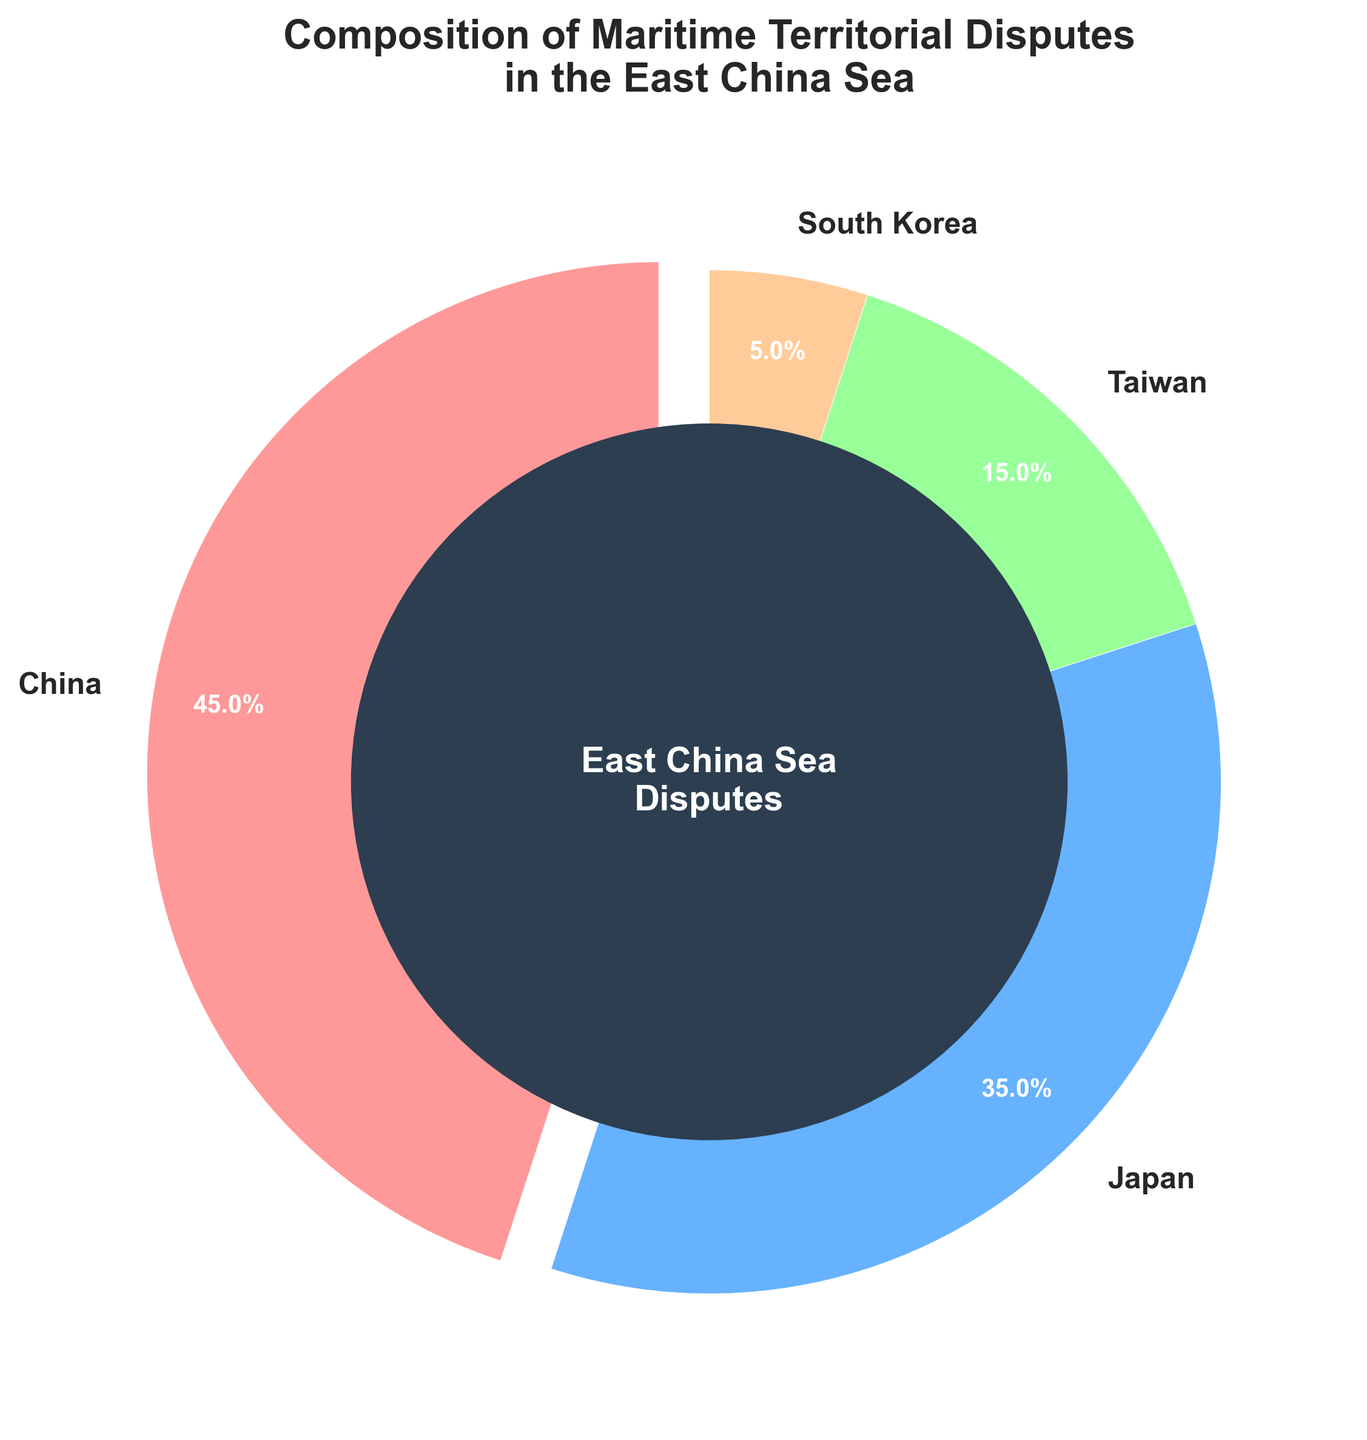What percentage of the disputed area is claimed by Japan and Taiwan together? Japan claims 35% and Taiwan claims 15%. Summing these gives 35% + 15% = 50%.
Answer: 50% Which country claims the smallest percentage of the disputed area? By observing the pie chart, South Korea has the smallest wedge with 5% of the disputed area.
Answer: South Korea How much more disputed area does China claim compared to South Korea? China claims 45% and South Korea claims 5%. The difference is 45% - 5% = 40%.
Answer: 40% Which country claims the largest percentage of the disputed area? By observing the pie chart, China has the largest wedge with 45% of the disputed area.
Answer: China What is the visual color representation of the disputed area claimed by Taiwan? The pie chart shows Taiwan's wedge colored in green.
Answer: Green How does the percentage of the disputed area claimed by Japan compare to that claimed by South Korea? Japan claims 35% and South Korea claims 5%. Japan claims 35% - 5% = 30% more.
Answer: 30% more Describe the visual location of the largest segment in the pie chart. The largest segment is located starting from the 90-degree mark in the clockwise direction and is labeled "China."
Answer: China What is the combined percentage of the disputed area claimed by China and South Korea? China claims 45% and South Korea claims 5%. Summing these gives 45% + 5% = 50%.
Answer: 50% Calculate the average percentage of the disputed area claimed by all four countries. Adding the percentages: 45% (China) + 35% (Japan) + 15% (Taiwan) + 5% (South Korea) = 100%. Dividing by 4 gives 100% / 4 = 25%.
Answer: 25% What color is used to represent the disputed area claimed by Japan, and what is its percentage? The pie chart shows Japan's wedge colored in blue and labeled with 35%.
Answer: Blue, 35% 